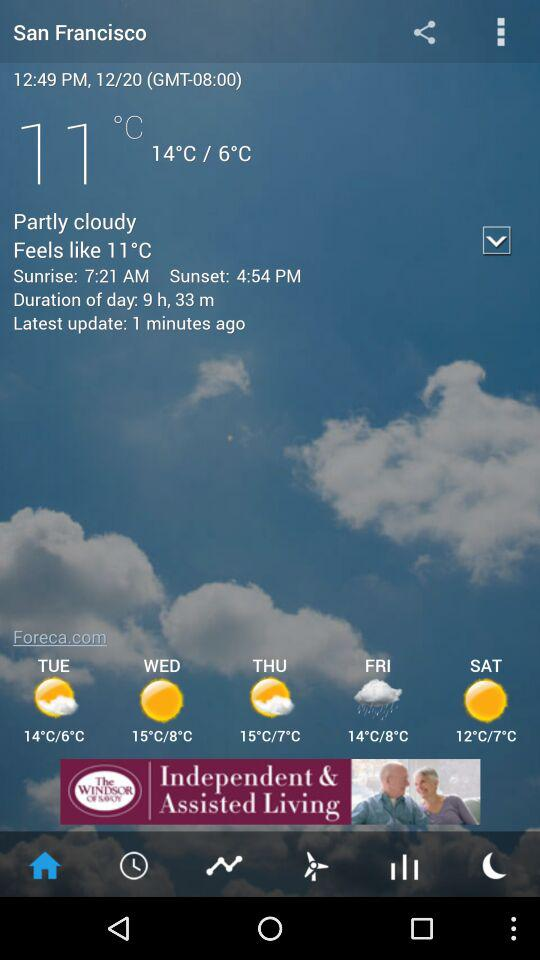What is the duration of the day? The duration of the day is 9 hours and 33 minutes. 